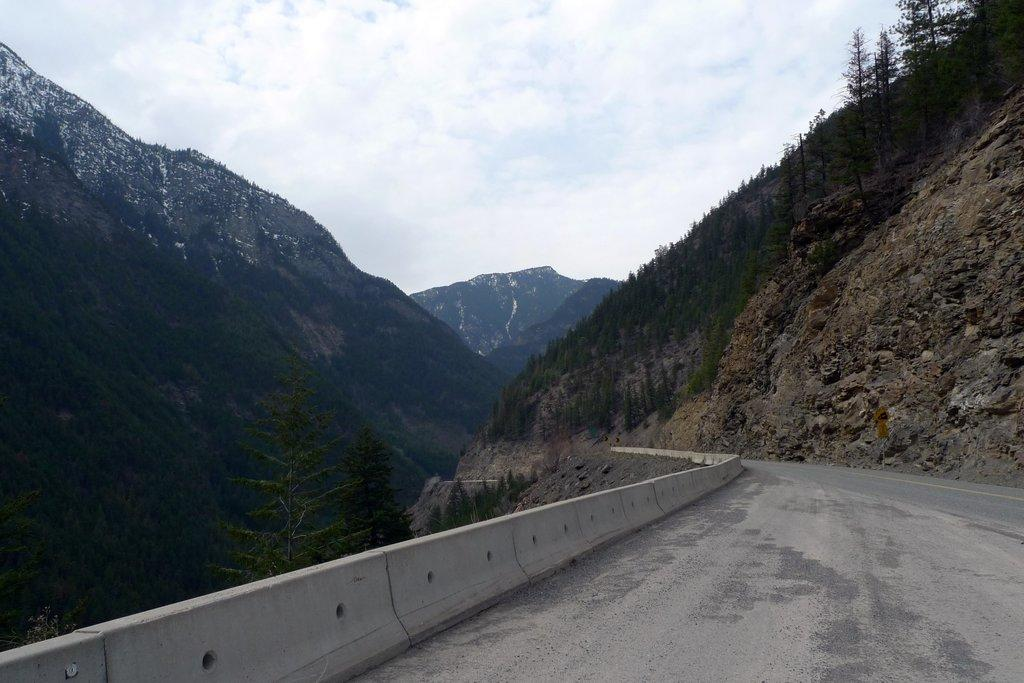What is the main feature of the image? There is a road in the image. What can be seen alongside the road? There are trees next to the road. What type of natural landmarks are visible in the image? There are mountains visible in the image. What is visible in the background of the image? There are clouds and the sky visible in the background. How many ducks are sitting on the chin of the person in the image? There is no person or ducks present in the image. 